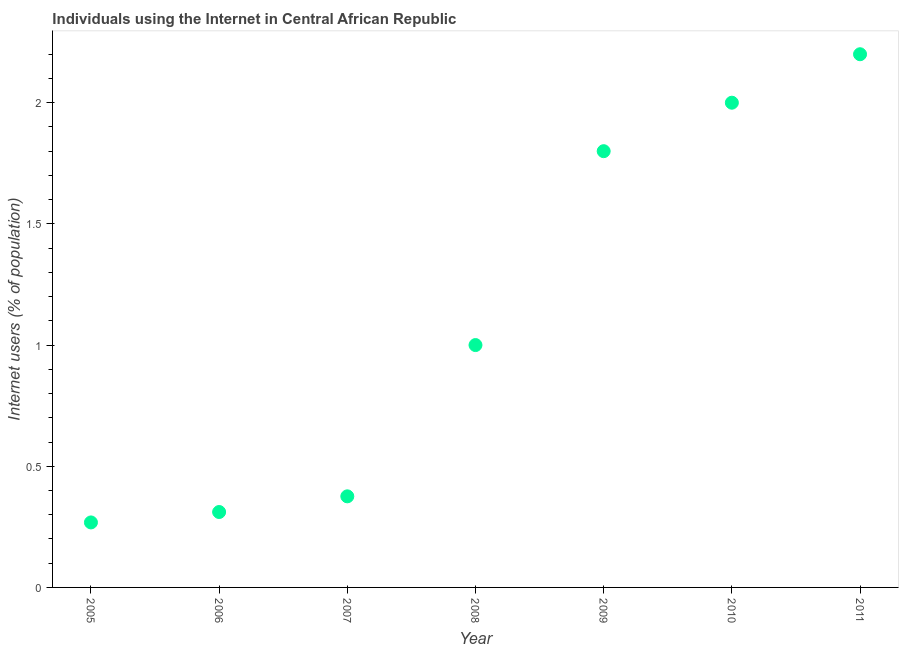What is the number of internet users in 2007?
Your answer should be compact. 0.38. Across all years, what is the maximum number of internet users?
Your answer should be very brief. 2.2. Across all years, what is the minimum number of internet users?
Offer a terse response. 0.27. In which year was the number of internet users maximum?
Provide a succinct answer. 2011. In which year was the number of internet users minimum?
Offer a very short reply. 2005. What is the sum of the number of internet users?
Ensure brevity in your answer.  7.96. What is the difference between the number of internet users in 2009 and 2011?
Offer a very short reply. -0.4. What is the average number of internet users per year?
Your answer should be very brief. 1.14. What is the median number of internet users?
Your answer should be compact. 1. Do a majority of the years between 2007 and 2011 (inclusive) have number of internet users greater than 0.7 %?
Offer a very short reply. Yes. What is the ratio of the number of internet users in 2005 to that in 2010?
Give a very brief answer. 0.13. What is the difference between the highest and the second highest number of internet users?
Keep it short and to the point. 0.2. What is the difference between the highest and the lowest number of internet users?
Provide a succinct answer. 1.93. Does the number of internet users monotonically increase over the years?
Keep it short and to the point. Yes. How many dotlines are there?
Your answer should be compact. 1. What is the difference between two consecutive major ticks on the Y-axis?
Make the answer very short. 0.5. What is the title of the graph?
Keep it short and to the point. Individuals using the Internet in Central African Republic. What is the label or title of the Y-axis?
Give a very brief answer. Internet users (% of population). What is the Internet users (% of population) in 2005?
Make the answer very short. 0.27. What is the Internet users (% of population) in 2006?
Offer a terse response. 0.31. What is the Internet users (% of population) in 2007?
Provide a succinct answer. 0.38. What is the Internet users (% of population) in 2008?
Your answer should be compact. 1. What is the Internet users (% of population) in 2010?
Your answer should be compact. 2. What is the difference between the Internet users (% of population) in 2005 and 2006?
Keep it short and to the point. -0.04. What is the difference between the Internet users (% of population) in 2005 and 2007?
Your answer should be compact. -0.11. What is the difference between the Internet users (% of population) in 2005 and 2008?
Provide a succinct answer. -0.73. What is the difference between the Internet users (% of population) in 2005 and 2009?
Offer a terse response. -1.53. What is the difference between the Internet users (% of population) in 2005 and 2010?
Your answer should be very brief. -1.73. What is the difference between the Internet users (% of population) in 2005 and 2011?
Offer a very short reply. -1.93. What is the difference between the Internet users (% of population) in 2006 and 2007?
Your answer should be very brief. -0.06. What is the difference between the Internet users (% of population) in 2006 and 2008?
Your answer should be compact. -0.69. What is the difference between the Internet users (% of population) in 2006 and 2009?
Offer a very short reply. -1.49. What is the difference between the Internet users (% of population) in 2006 and 2010?
Provide a short and direct response. -1.69. What is the difference between the Internet users (% of population) in 2006 and 2011?
Give a very brief answer. -1.89. What is the difference between the Internet users (% of population) in 2007 and 2008?
Your answer should be very brief. -0.62. What is the difference between the Internet users (% of population) in 2007 and 2009?
Make the answer very short. -1.42. What is the difference between the Internet users (% of population) in 2007 and 2010?
Your answer should be compact. -1.62. What is the difference between the Internet users (% of population) in 2007 and 2011?
Provide a short and direct response. -1.82. What is the difference between the Internet users (% of population) in 2009 and 2011?
Your response must be concise. -0.4. What is the ratio of the Internet users (% of population) in 2005 to that in 2006?
Ensure brevity in your answer.  0.86. What is the ratio of the Internet users (% of population) in 2005 to that in 2007?
Ensure brevity in your answer.  0.71. What is the ratio of the Internet users (% of population) in 2005 to that in 2008?
Your answer should be compact. 0.27. What is the ratio of the Internet users (% of population) in 2005 to that in 2009?
Provide a short and direct response. 0.15. What is the ratio of the Internet users (% of population) in 2005 to that in 2010?
Provide a short and direct response. 0.13. What is the ratio of the Internet users (% of population) in 2005 to that in 2011?
Your answer should be very brief. 0.12. What is the ratio of the Internet users (% of population) in 2006 to that in 2007?
Your response must be concise. 0.83. What is the ratio of the Internet users (% of population) in 2006 to that in 2008?
Give a very brief answer. 0.31. What is the ratio of the Internet users (% of population) in 2006 to that in 2009?
Provide a succinct answer. 0.17. What is the ratio of the Internet users (% of population) in 2006 to that in 2010?
Ensure brevity in your answer.  0.16. What is the ratio of the Internet users (% of population) in 2006 to that in 2011?
Provide a succinct answer. 0.14. What is the ratio of the Internet users (% of population) in 2007 to that in 2008?
Offer a terse response. 0.38. What is the ratio of the Internet users (% of population) in 2007 to that in 2009?
Provide a succinct answer. 0.21. What is the ratio of the Internet users (% of population) in 2007 to that in 2010?
Your response must be concise. 0.19. What is the ratio of the Internet users (% of population) in 2007 to that in 2011?
Provide a short and direct response. 0.17. What is the ratio of the Internet users (% of population) in 2008 to that in 2009?
Provide a short and direct response. 0.56. What is the ratio of the Internet users (% of population) in 2008 to that in 2011?
Your answer should be very brief. 0.46. What is the ratio of the Internet users (% of population) in 2009 to that in 2011?
Your response must be concise. 0.82. What is the ratio of the Internet users (% of population) in 2010 to that in 2011?
Ensure brevity in your answer.  0.91. 